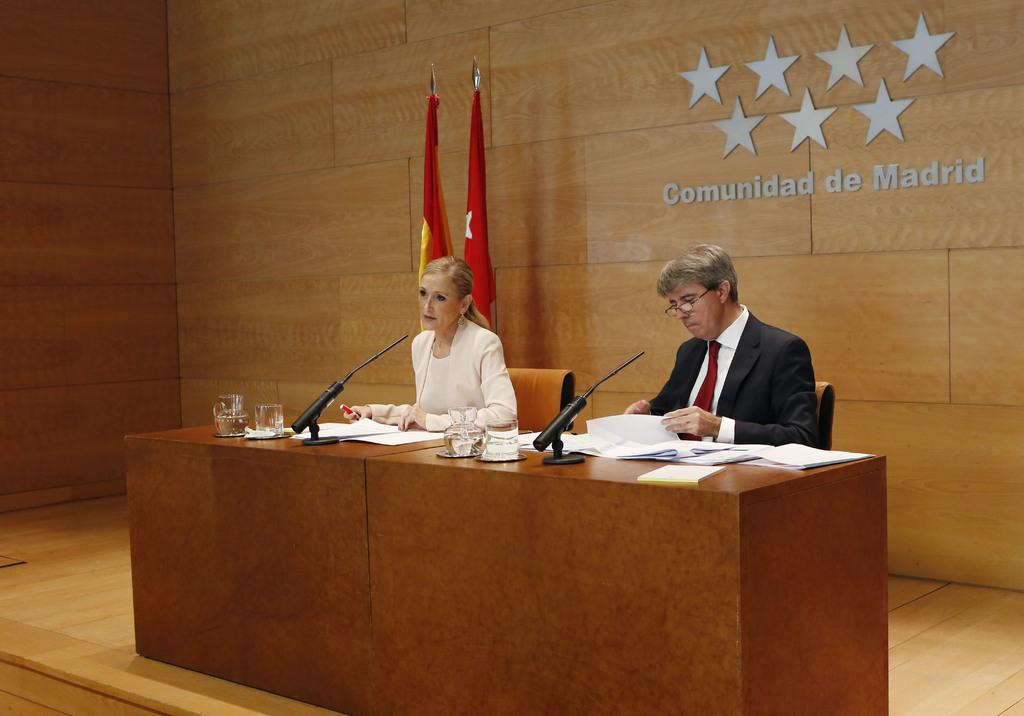How many people are in the image? There are two people in the image, a man and a woman. What are the man and woman doing in the image? Both the man and woman are sitting on chairs. What objects are on the table in front of them? There are glasses, microphones (mics), and papers on the table in front of them. How many flags are visible in the image? There are two flags visible in the image. What can be seen on the wall in the background? There is a wall with a logo on it in the background. What type of mailbox is visible in the image? There is no mailbox present in the image. 